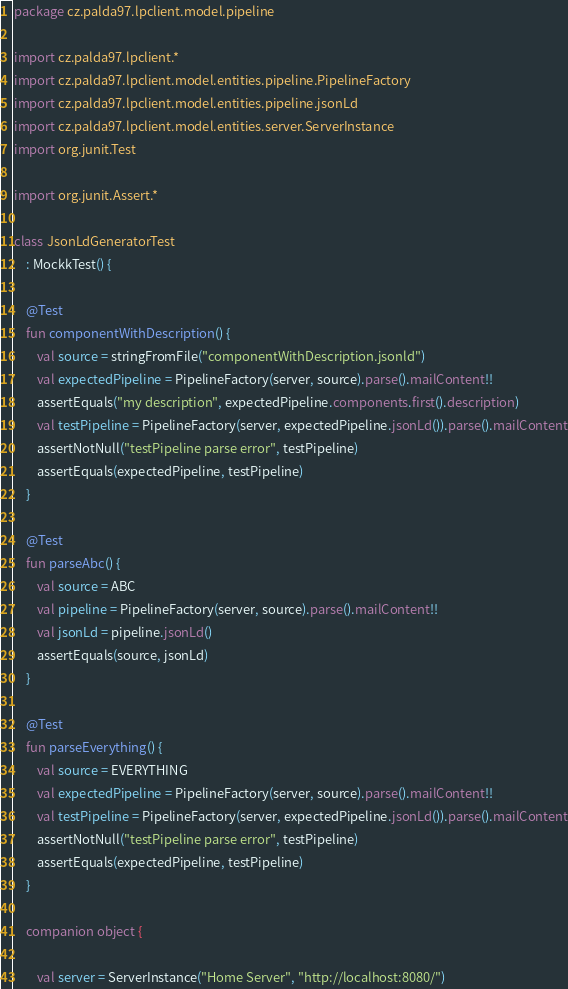<code> <loc_0><loc_0><loc_500><loc_500><_Kotlin_>package cz.palda97.lpclient.model.pipeline

import cz.palda97.lpclient.*
import cz.palda97.lpclient.model.entities.pipeline.PipelineFactory
import cz.palda97.lpclient.model.entities.pipeline.jsonLd
import cz.palda97.lpclient.model.entities.server.ServerInstance
import org.junit.Test

import org.junit.Assert.*

class JsonLdGeneratorTest
    : MockkTest() {

    @Test
    fun componentWithDescription() {
        val source = stringFromFile("componentWithDescription.jsonld")
        val expectedPipeline = PipelineFactory(server, source).parse().mailContent!!
        assertEquals("my description", expectedPipeline.components.first().description)
        val testPipeline = PipelineFactory(server, expectedPipeline.jsonLd()).parse().mailContent
        assertNotNull("testPipeline parse error", testPipeline)
        assertEquals(expectedPipeline, testPipeline)
    }

    @Test
    fun parseAbc() {
        val source = ABC
        val pipeline = PipelineFactory(server, source).parse().mailContent!!
        val jsonLd = pipeline.jsonLd()
        assertEquals(source, jsonLd)
    }

    @Test
    fun parseEverything() {
        val source = EVERYTHING
        val expectedPipeline = PipelineFactory(server, source).parse().mailContent!!
        val testPipeline = PipelineFactory(server, expectedPipeline.jsonLd()).parse().mailContent
        assertNotNull("testPipeline parse error", testPipeline)
        assertEquals(expectedPipeline, testPipeline)
    }

    companion object {

        val server = ServerInstance("Home Server", "http://localhost:8080/")
</code> 